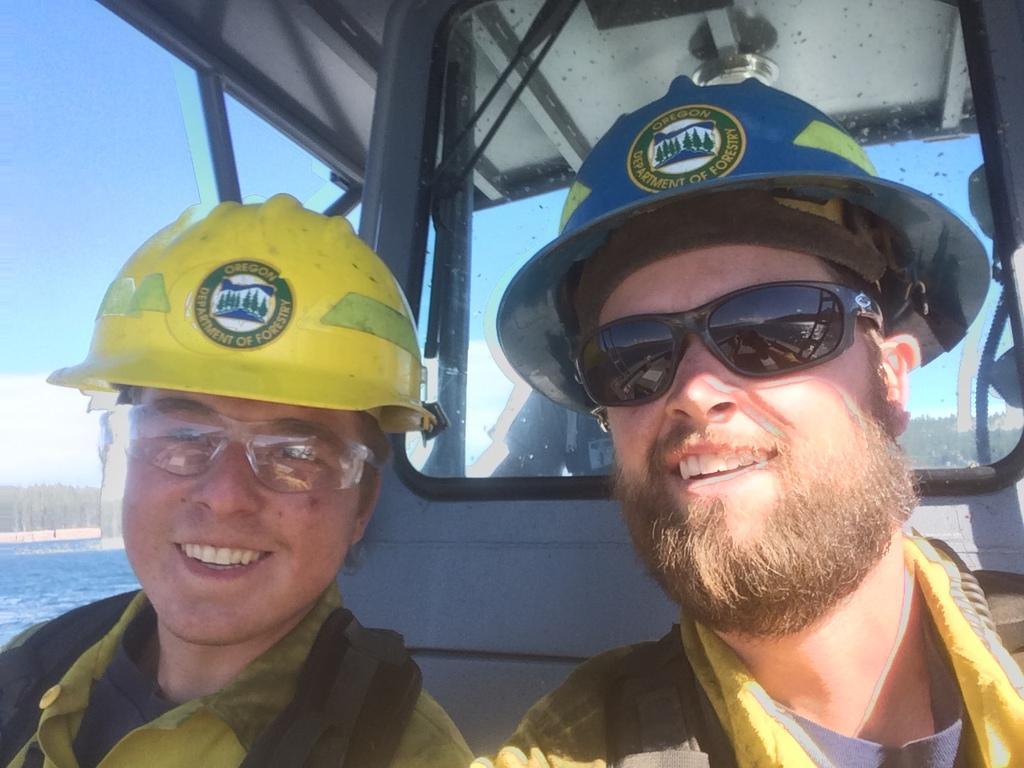Describe this image in one or two sentences. In the foreground of the picture we can see people in a vehicle, they are wearing helmets and spectacles. On the left we can see a water body. In the middle of the picture there are trees. At the top there is sky. 